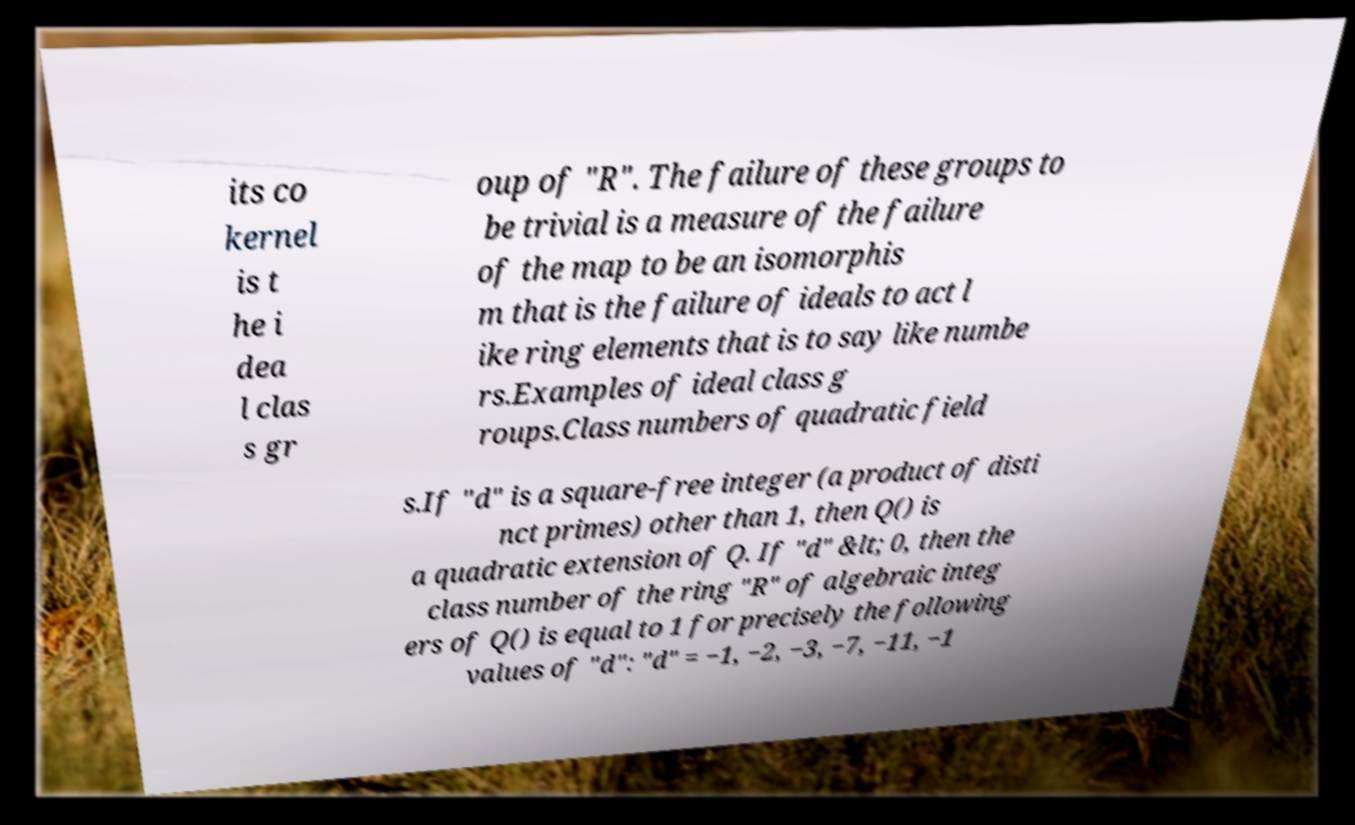Can you read and provide the text displayed in the image?This photo seems to have some interesting text. Can you extract and type it out for me? its co kernel is t he i dea l clas s gr oup of "R". The failure of these groups to be trivial is a measure of the failure of the map to be an isomorphis m that is the failure of ideals to act l ike ring elements that is to say like numbe rs.Examples of ideal class g roups.Class numbers of quadratic field s.If "d" is a square-free integer (a product of disti nct primes) other than 1, then Q() is a quadratic extension of Q. If "d" &lt; 0, then the class number of the ring "R" of algebraic integ ers of Q() is equal to 1 for precisely the following values of "d": "d" = −1, −2, −3, −7, −11, −1 